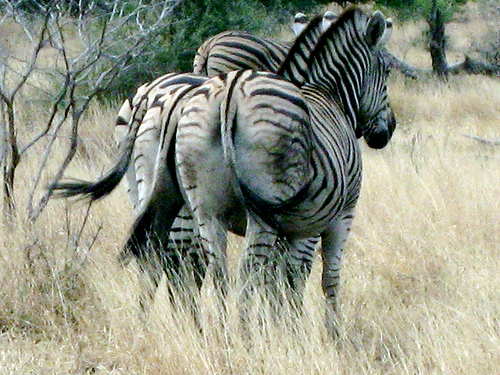How many zebras are there? There are two zebras in the image, identifiable by their distinct black and white striped patterns which are unique to each individual much like fingerprints in humans. 